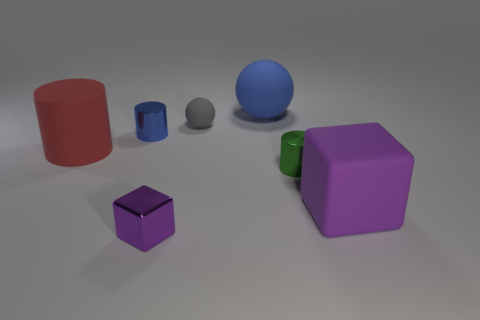What material is the large object that is the same color as the shiny cube?
Provide a short and direct response. Rubber. How many tiny objects have the same color as the matte cylinder?
Make the answer very short. 0. What shape is the purple object in front of the matte object in front of the tiny green cylinder?
Give a very brief answer. Cube. Are there any tiny metallic things of the same shape as the large blue matte thing?
Keep it short and to the point. No. There is a tiny metallic cube; is its color the same as the matte thing that is in front of the large cylinder?
Provide a short and direct response. Yes. What is the size of the metallic thing that is the same color as the large ball?
Ensure brevity in your answer.  Small. Is there a green matte cylinder that has the same size as the red matte object?
Your answer should be very brief. No. Do the green cylinder and the tiny cylinder behind the large red thing have the same material?
Provide a short and direct response. Yes. Is the number of big blue blocks greater than the number of big cylinders?
Keep it short and to the point. No. How many spheres are either purple shiny things or gray things?
Give a very brief answer. 1. 